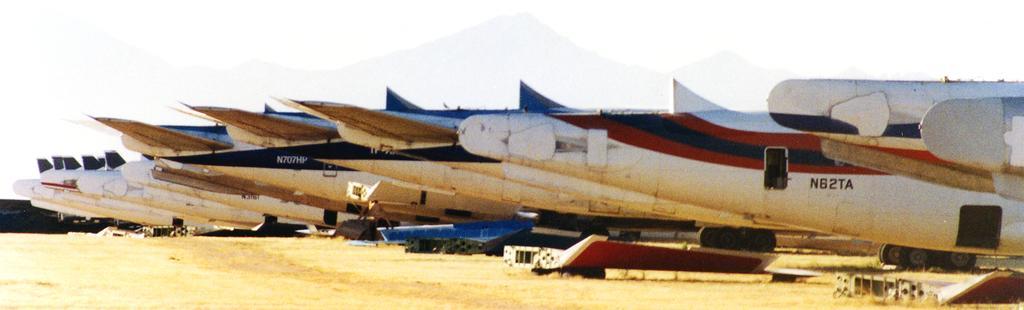Could you give a brief overview of what you see in this image? In the picture we can see a path to it, we can see a number of planes which are parked, some planes are white and red in color and some are blue and white in color and behind it we can see some hills and sky. 